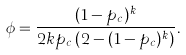Convert formula to latex. <formula><loc_0><loc_0><loc_500><loc_500>\phi = \frac { ( 1 - p _ { c } ) ^ { k } } { 2 k p _ { c } \, ( 2 - ( 1 - p _ { c } ) ^ { k } ) } .</formula> 